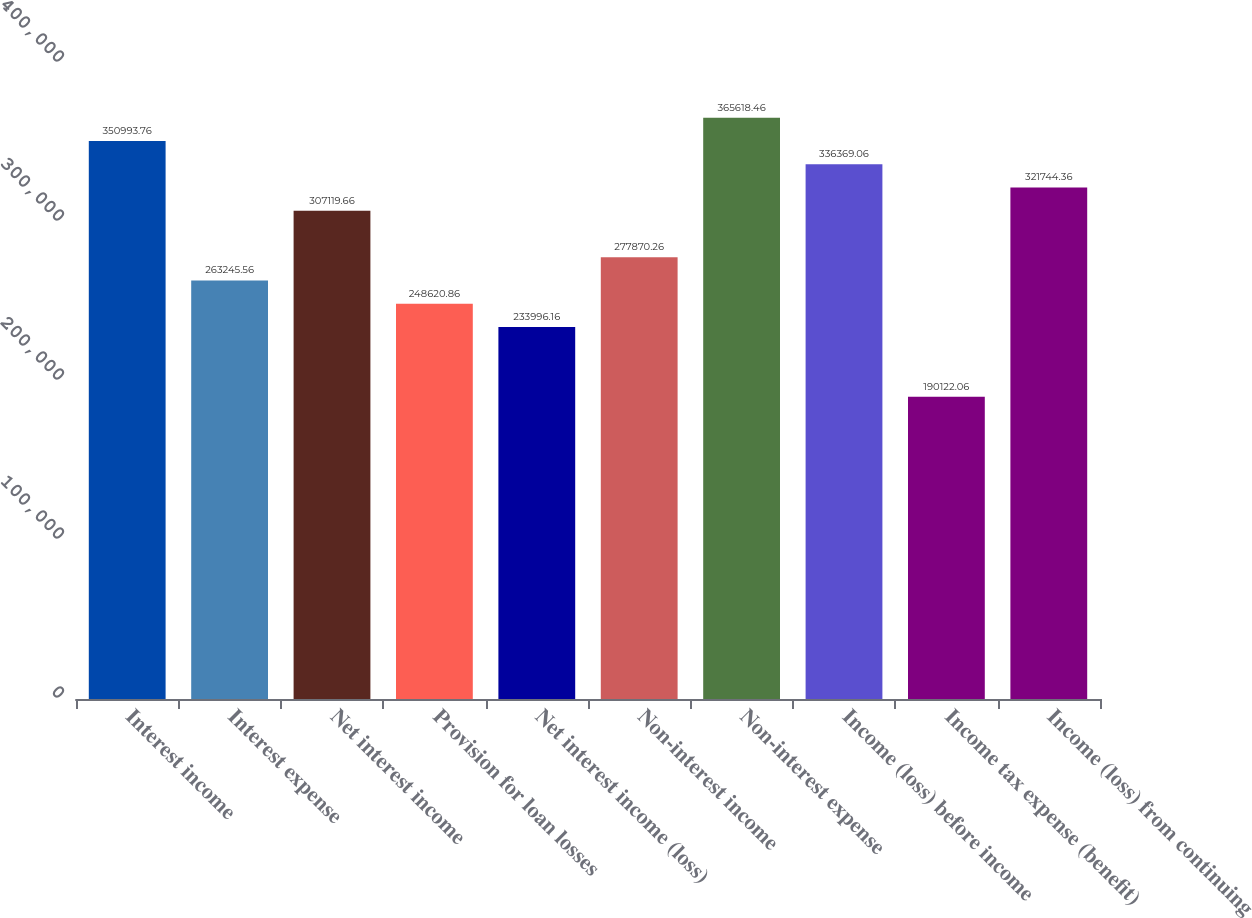<chart> <loc_0><loc_0><loc_500><loc_500><bar_chart><fcel>Interest income<fcel>Interest expense<fcel>Net interest income<fcel>Provision for loan losses<fcel>Net interest income (loss)<fcel>Non-interest income<fcel>Non-interest expense<fcel>Income (loss) before income<fcel>Income tax expense (benefit)<fcel>Income (loss) from continuing<nl><fcel>350994<fcel>263246<fcel>307120<fcel>248621<fcel>233996<fcel>277870<fcel>365618<fcel>336369<fcel>190122<fcel>321744<nl></chart> 